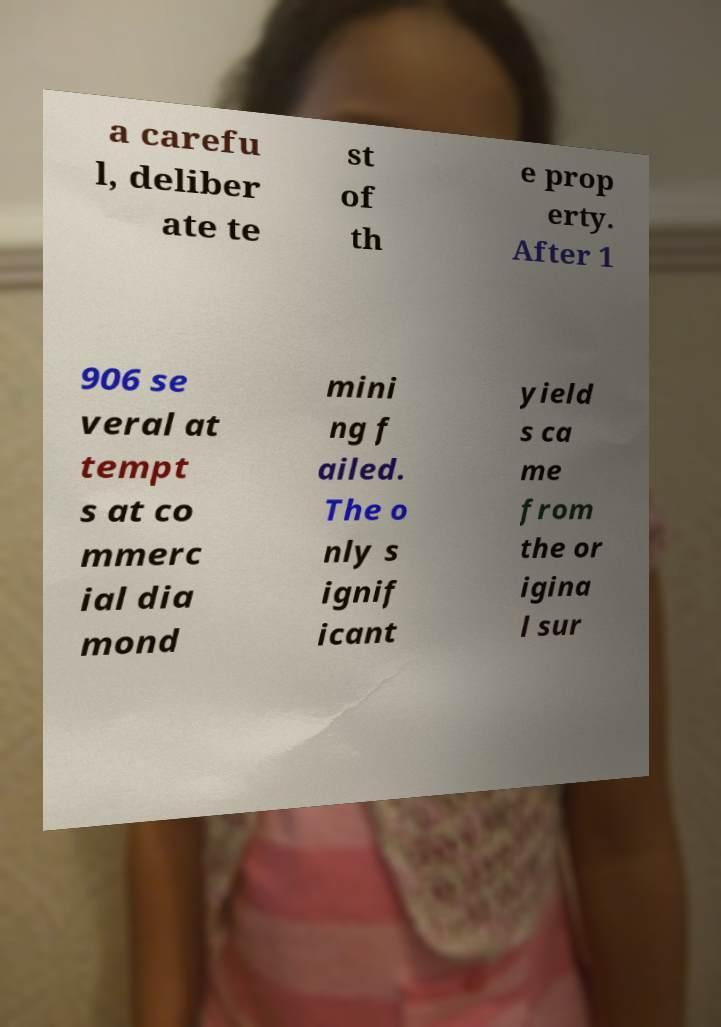For documentation purposes, I need the text within this image transcribed. Could you provide that? a carefu l, deliber ate te st of th e prop erty. After 1 906 se veral at tempt s at co mmerc ial dia mond mini ng f ailed. The o nly s ignif icant yield s ca me from the or igina l sur 